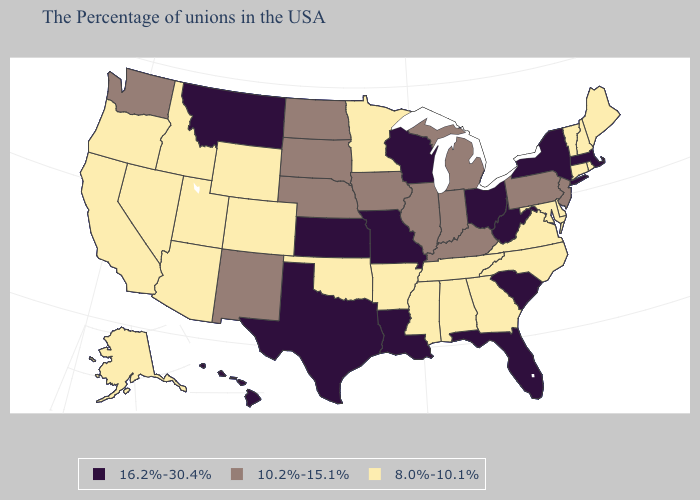Name the states that have a value in the range 10.2%-15.1%?
Be succinct. New Jersey, Pennsylvania, Michigan, Kentucky, Indiana, Illinois, Iowa, Nebraska, South Dakota, North Dakota, New Mexico, Washington. Name the states that have a value in the range 8.0%-10.1%?
Keep it brief. Maine, Rhode Island, New Hampshire, Vermont, Connecticut, Delaware, Maryland, Virginia, North Carolina, Georgia, Alabama, Tennessee, Mississippi, Arkansas, Minnesota, Oklahoma, Wyoming, Colorado, Utah, Arizona, Idaho, Nevada, California, Oregon, Alaska. What is the lowest value in the MidWest?
Short answer required. 8.0%-10.1%. Does the first symbol in the legend represent the smallest category?
Answer briefly. No. Name the states that have a value in the range 16.2%-30.4%?
Give a very brief answer. Massachusetts, New York, South Carolina, West Virginia, Ohio, Florida, Wisconsin, Louisiana, Missouri, Kansas, Texas, Montana, Hawaii. Does California have the lowest value in the USA?
Short answer required. Yes. Does the first symbol in the legend represent the smallest category?
Short answer required. No. What is the lowest value in the South?
Give a very brief answer. 8.0%-10.1%. Name the states that have a value in the range 8.0%-10.1%?
Short answer required. Maine, Rhode Island, New Hampshire, Vermont, Connecticut, Delaware, Maryland, Virginia, North Carolina, Georgia, Alabama, Tennessee, Mississippi, Arkansas, Minnesota, Oklahoma, Wyoming, Colorado, Utah, Arizona, Idaho, Nevada, California, Oregon, Alaska. Name the states that have a value in the range 16.2%-30.4%?
Be succinct. Massachusetts, New York, South Carolina, West Virginia, Ohio, Florida, Wisconsin, Louisiana, Missouri, Kansas, Texas, Montana, Hawaii. Does New Mexico have a higher value than Kansas?
Short answer required. No. Is the legend a continuous bar?
Short answer required. No. Among the states that border Minnesota , does North Dakota have the highest value?
Keep it brief. No. What is the lowest value in the West?
Concise answer only. 8.0%-10.1%. Does Florida have the lowest value in the South?
Short answer required. No. 